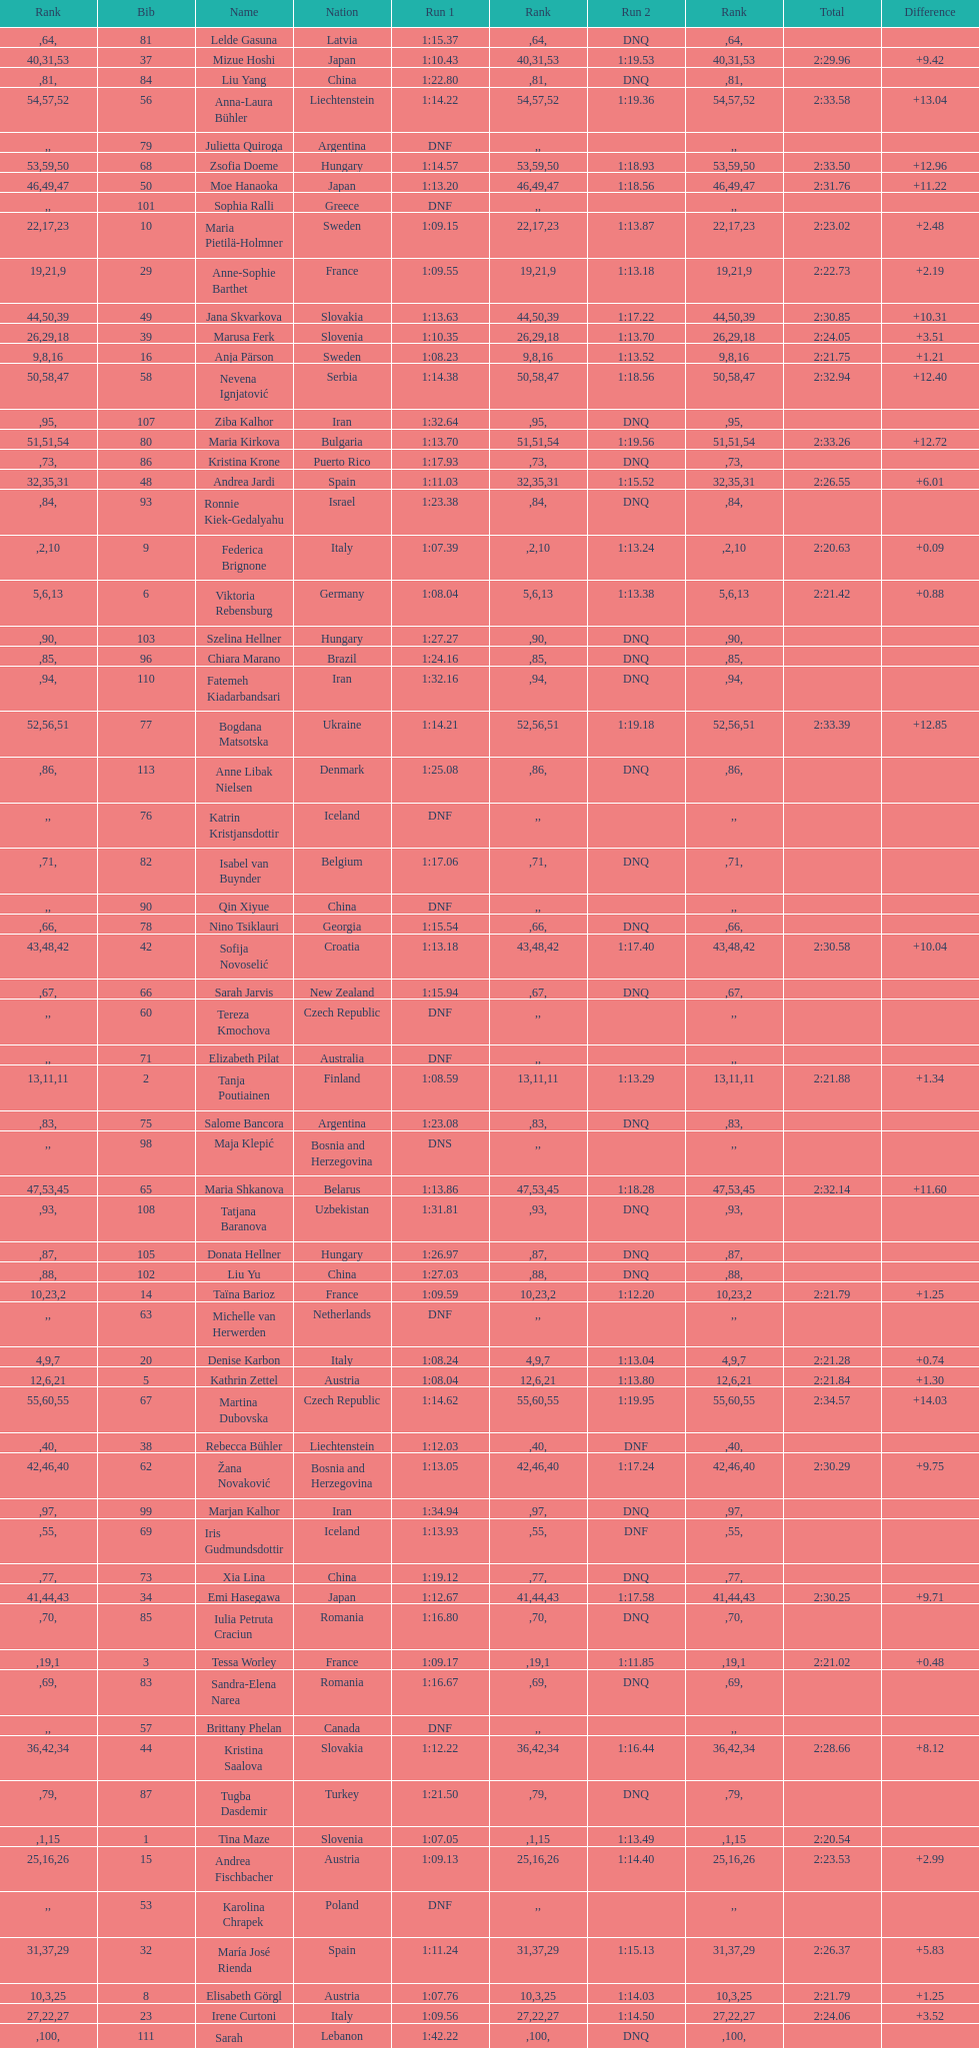How many total names are there? 116. 